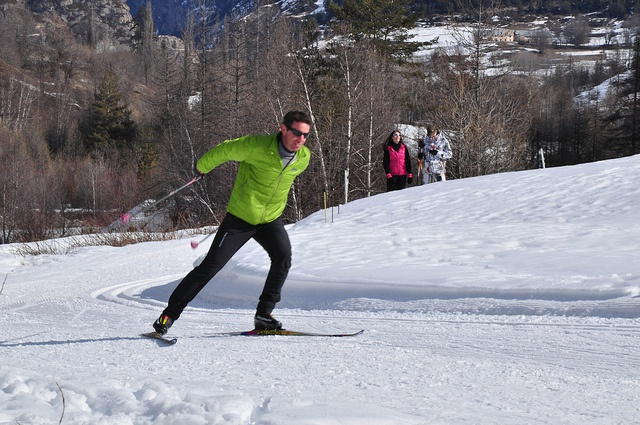Describe the objects in this image and their specific colors. I can see people in black, olive, and darkgreen tones, skis in black, lightgray, gray, and darkgray tones, people in black, gray, darkgray, and lavender tones, and people in black, brown, and maroon tones in this image. 